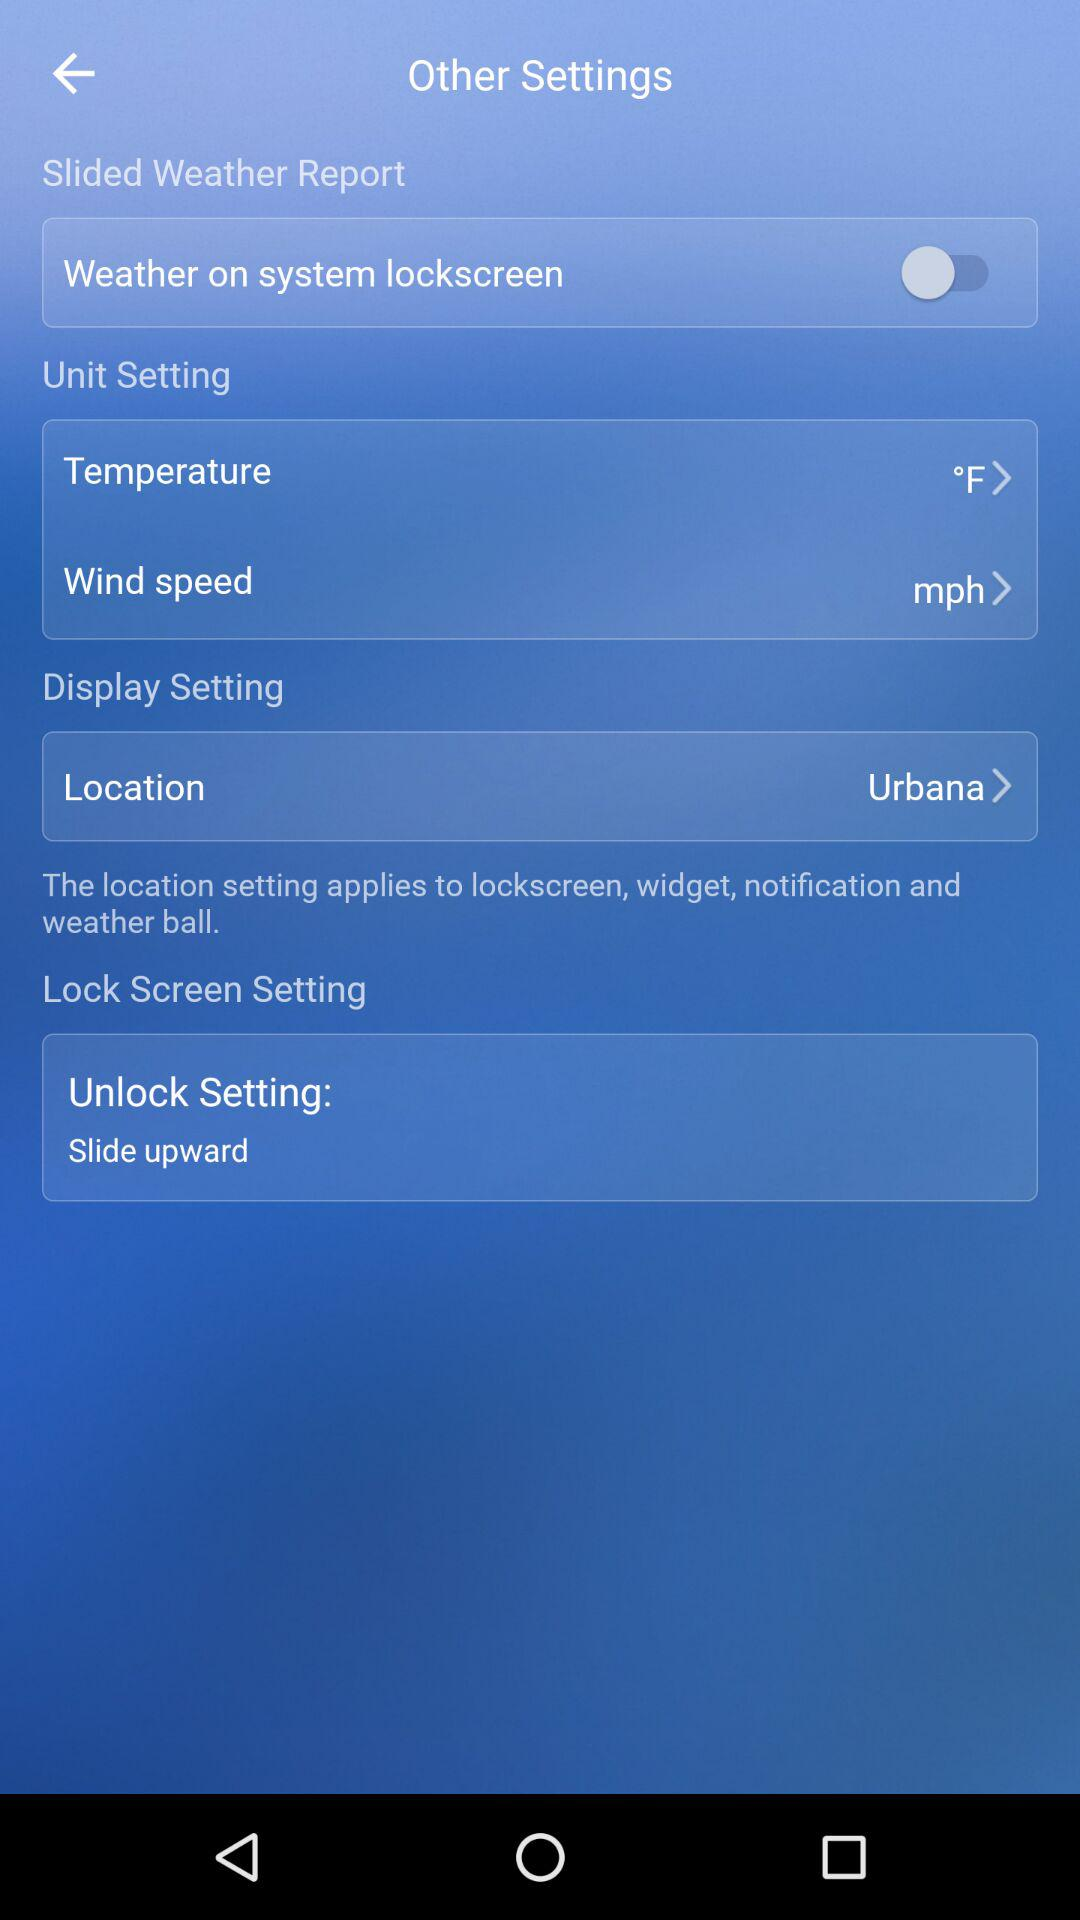What is the unit of temperature? The unit of temperature is °F. 